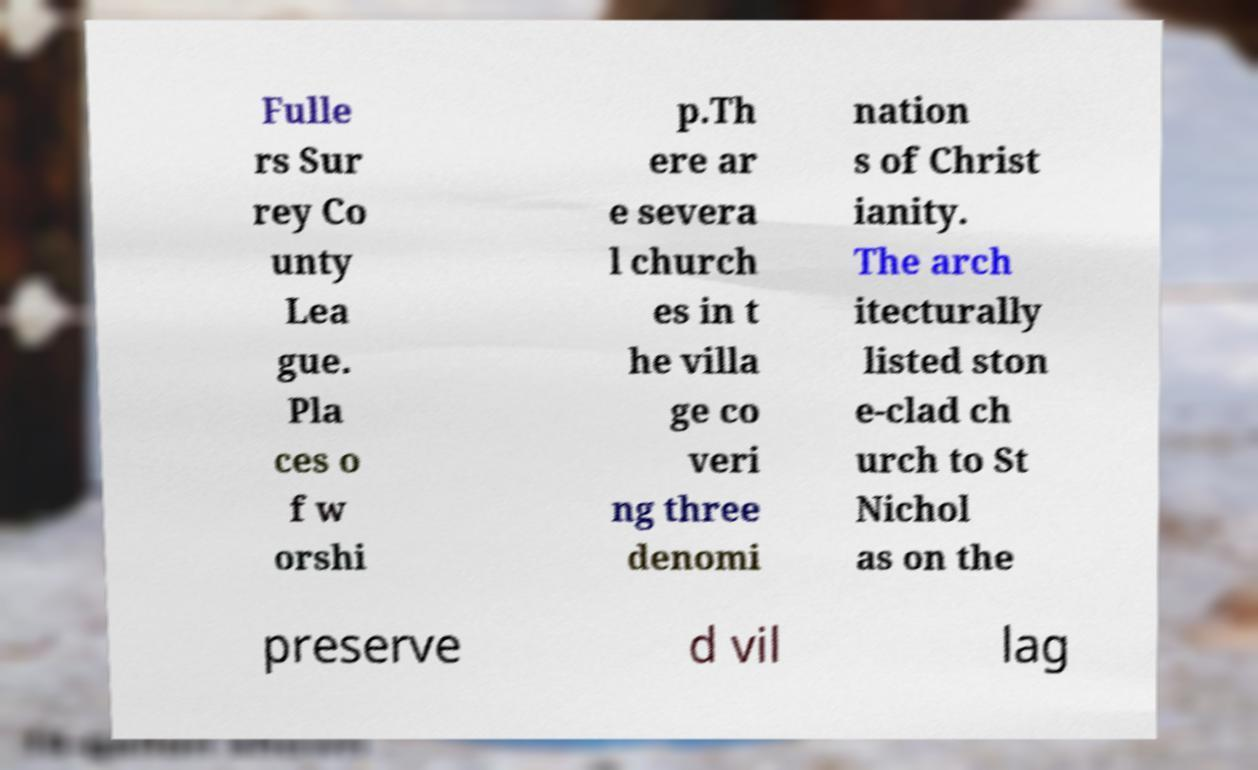Could you assist in decoding the text presented in this image and type it out clearly? Fulle rs Sur rey Co unty Lea gue. Pla ces o f w orshi p.Th ere ar e severa l church es in t he villa ge co veri ng three denomi nation s of Christ ianity. The arch itecturally listed ston e-clad ch urch to St Nichol as on the preserve d vil lag 